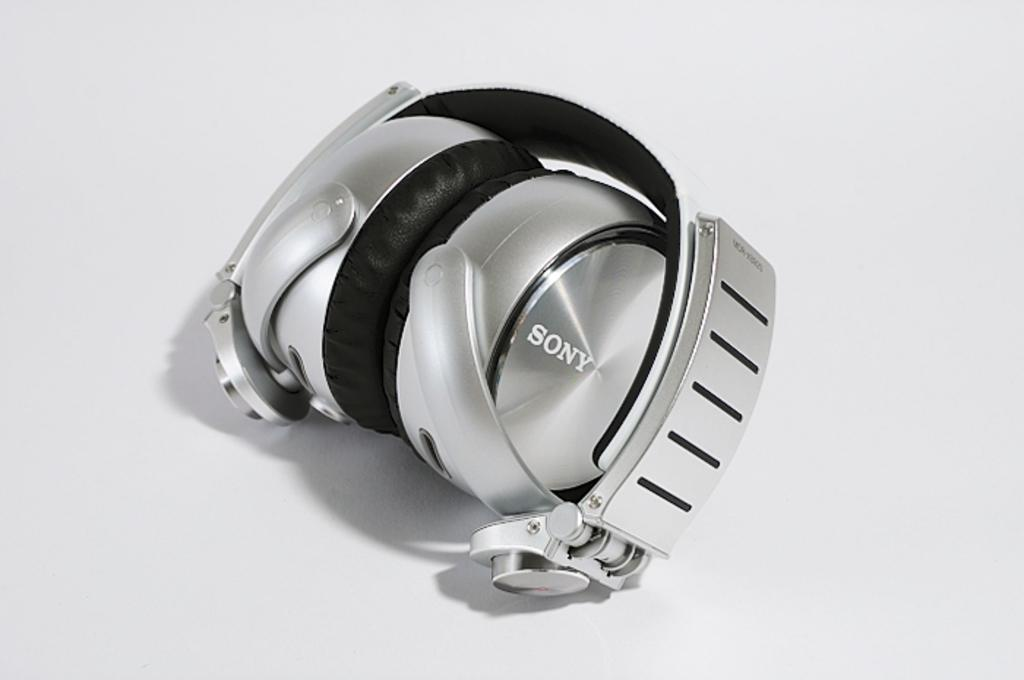<image>
Present a compact description of the photo's key features. A pair of Sony brand headphones is on display. 